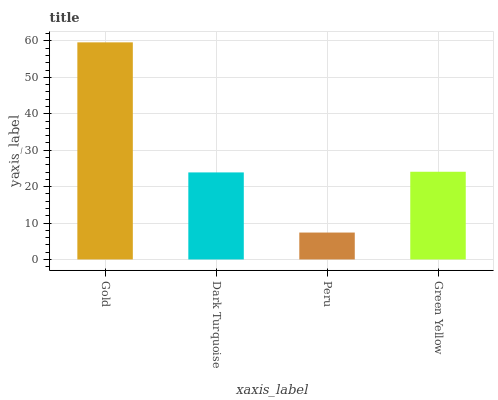Is Peru the minimum?
Answer yes or no. Yes. Is Gold the maximum?
Answer yes or no. Yes. Is Dark Turquoise the minimum?
Answer yes or no. No. Is Dark Turquoise the maximum?
Answer yes or no. No. Is Gold greater than Dark Turquoise?
Answer yes or no. Yes. Is Dark Turquoise less than Gold?
Answer yes or no. Yes. Is Dark Turquoise greater than Gold?
Answer yes or no. No. Is Gold less than Dark Turquoise?
Answer yes or no. No. Is Green Yellow the high median?
Answer yes or no. Yes. Is Dark Turquoise the low median?
Answer yes or no. Yes. Is Gold the high median?
Answer yes or no. No. Is Green Yellow the low median?
Answer yes or no. No. 